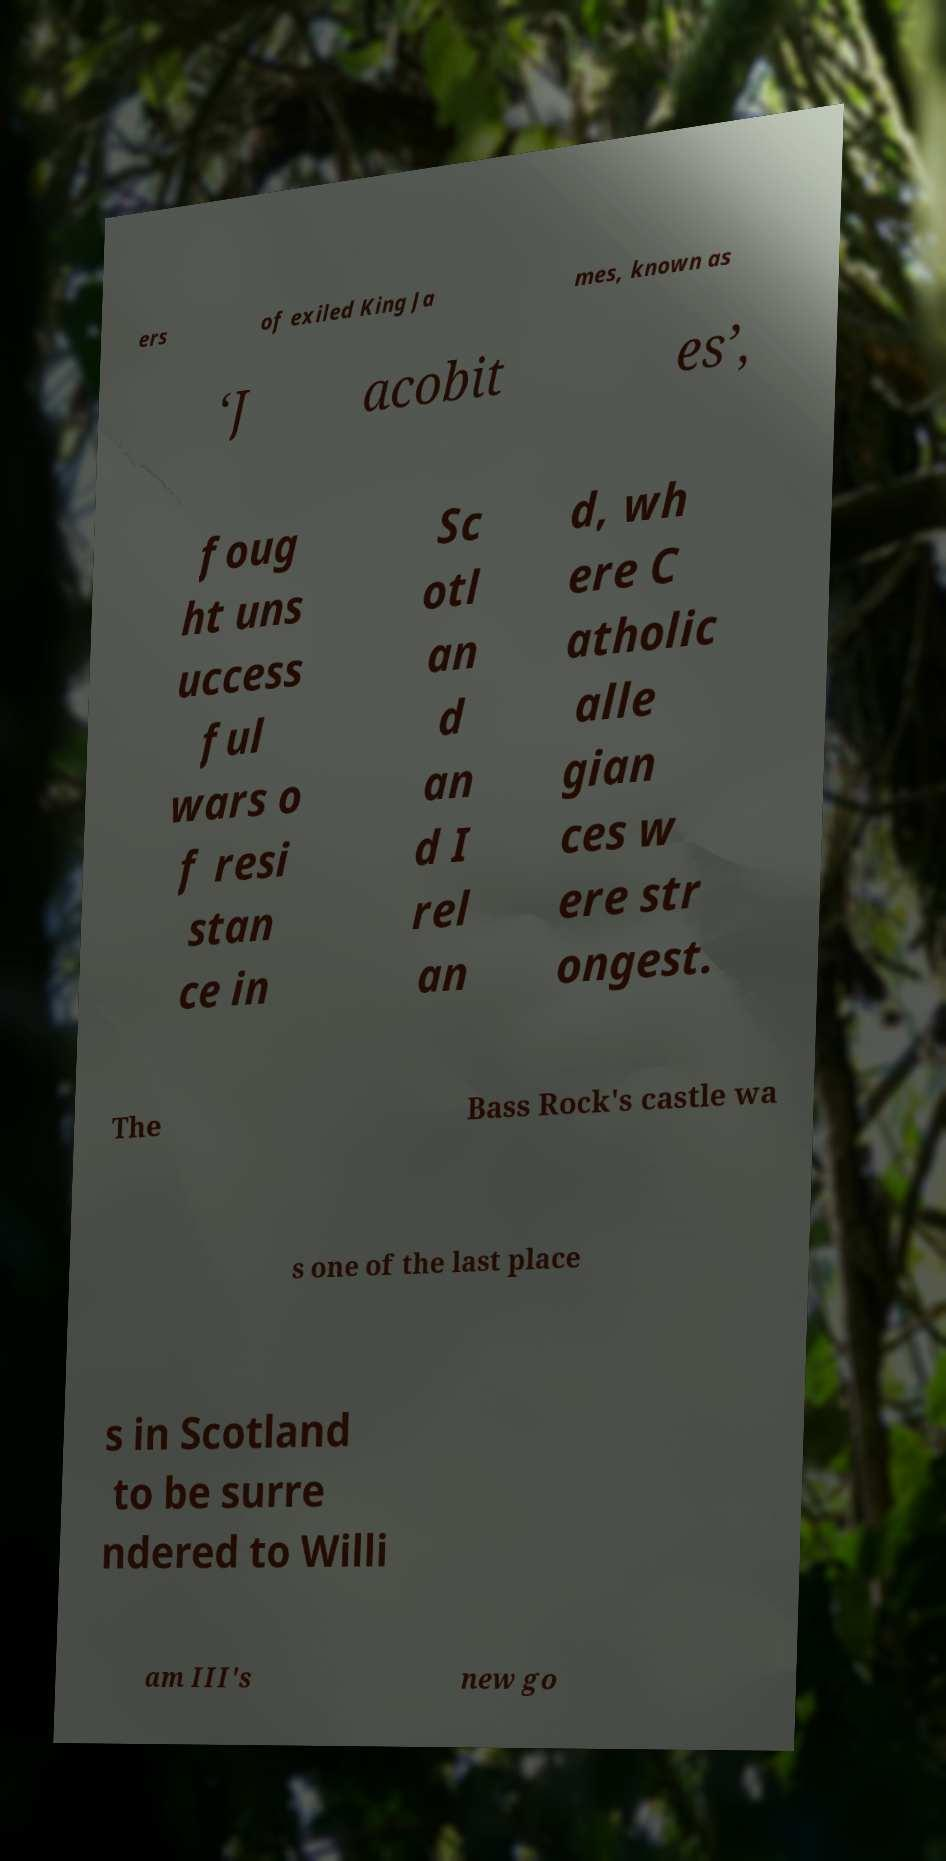Can you read and provide the text displayed in the image?This photo seems to have some interesting text. Can you extract and type it out for me? ers of exiled King Ja mes, known as ‘J acobit es’, foug ht uns uccess ful wars o f resi stan ce in Sc otl an d an d I rel an d, wh ere C atholic alle gian ces w ere str ongest. The Bass Rock's castle wa s one of the last place s in Scotland to be surre ndered to Willi am III's new go 